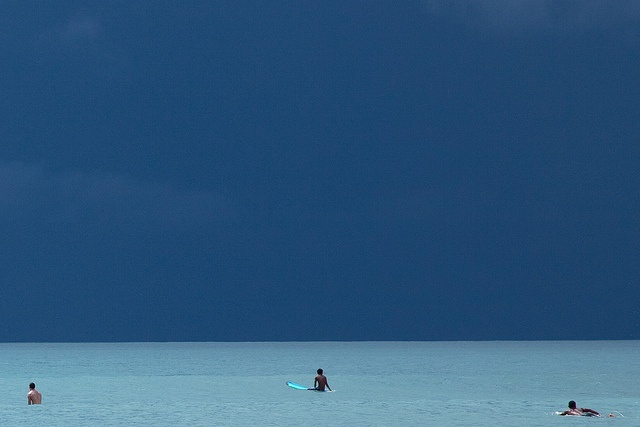Describe the objects in this image and their specific colors. I can see people in blue, black, gray, darkgray, and purple tones, people in blue, black, gray, and teal tones, people in blue, gray, black, and darkgray tones, surfboard in blue, cyan, teal, and lightblue tones, and surfboard in blue, lightgray, lightblue, and darkgray tones in this image. 